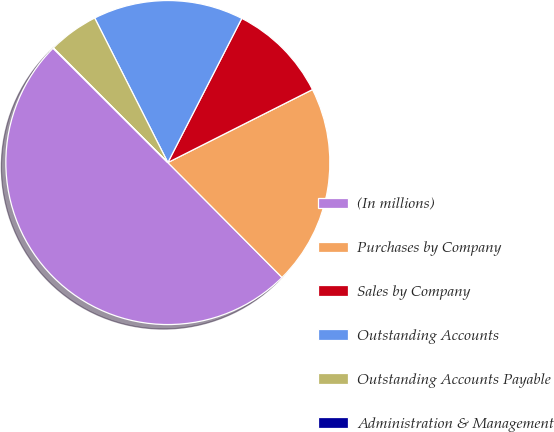Convert chart. <chart><loc_0><loc_0><loc_500><loc_500><pie_chart><fcel>(In millions)<fcel>Purchases by Company<fcel>Sales by Company<fcel>Outstanding Accounts<fcel>Outstanding Accounts Payable<fcel>Administration & Management<nl><fcel>49.92%<fcel>19.99%<fcel>10.02%<fcel>15.0%<fcel>5.03%<fcel>0.04%<nl></chart> 